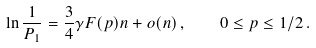<formula> <loc_0><loc_0><loc_500><loc_500>\ln \frac { 1 } { P _ { 1 } } = \frac { 3 } { 4 } \gamma F ( p ) n + o ( n ) \, , \quad 0 \leq p \leq 1 / 2 \, .</formula> 